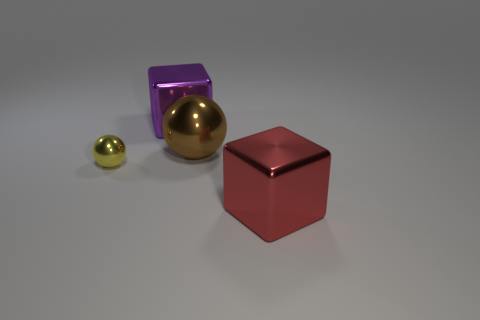How many brown balls are in front of the large block on the right side of the large metallic block that is behind the red thing?
Ensure brevity in your answer.  0. Does the purple thing have the same shape as the object that is in front of the tiny yellow object?
Ensure brevity in your answer.  Yes. What color is the object that is both behind the yellow thing and in front of the purple shiny block?
Provide a short and direct response. Brown. The big block behind the cube that is in front of the big metal block that is to the left of the big red metal cube is made of what material?
Make the answer very short. Metal. What is the brown object made of?
Offer a terse response. Metal. What size is the purple metal object that is the same shape as the red object?
Keep it short and to the point. Large. Do the small object and the big metallic ball have the same color?
Provide a short and direct response. No. What number of other things are made of the same material as the small yellow ball?
Your response must be concise. 3. Are there an equal number of small yellow spheres that are on the right side of the red shiny cube and brown metal balls?
Your response must be concise. No. Does the metal cube behind the red cube have the same size as the yellow metal sphere?
Make the answer very short. No. 